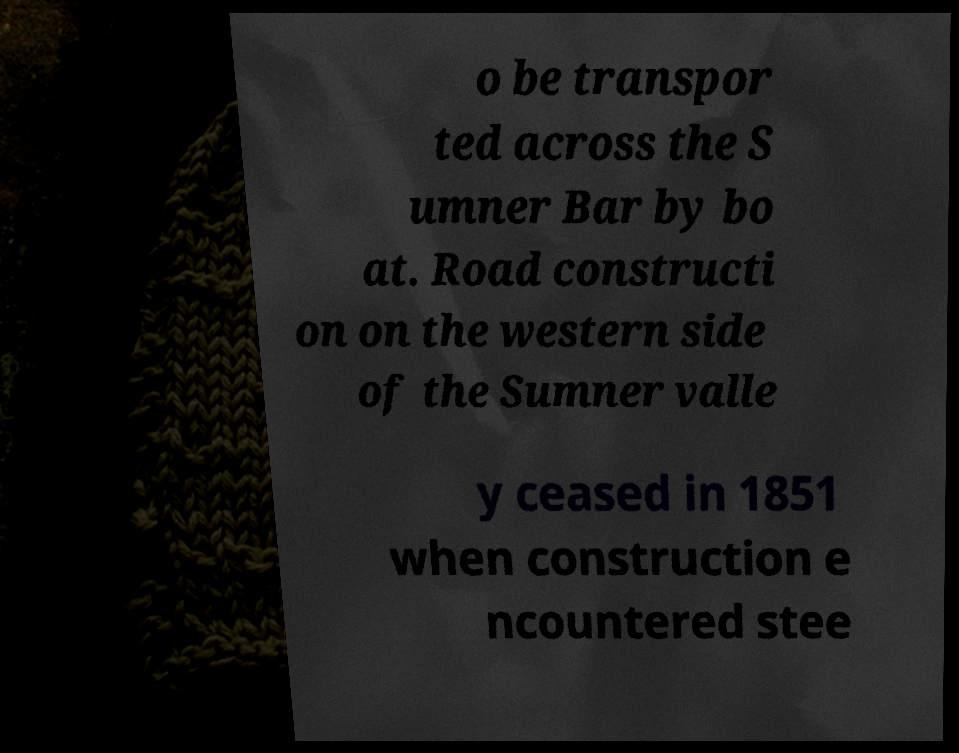Could you assist in decoding the text presented in this image and type it out clearly? o be transpor ted across the S umner Bar by bo at. Road constructi on on the western side of the Sumner valle y ceased in 1851 when construction e ncountered stee 